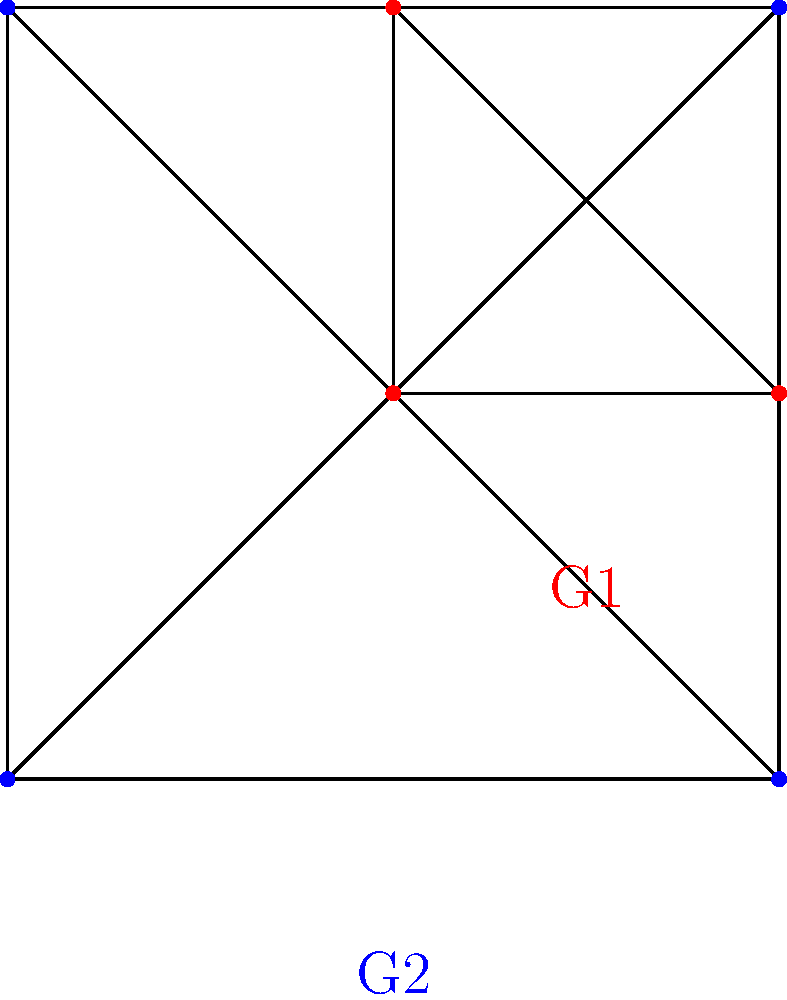Consider the two graphs G1 (red) and G2 (blue) shown above. Each graph represents a group where the vertices are the elements and the edges represent the group operation. Prove that these two groups are isomorphic by constructing an isomorphism $\phi: G1 \rightarrow G2$ that preserves the graph structure. What is the order of these groups? To prove that G1 and G2 are isomorphic, we need to construct a bijective function $\phi: G1 \rightarrow G2$ that preserves the group operation. Let's approach this step-by-step:

1) First, note that both graphs are complete graphs with 4 vertices. This means every vertex is connected to every other vertex.

2) In group theory, this structure represents Klein's four-group, also known as $V_4$ or $C_2 \times C_2$.

3) Let's label the vertices of G1 as $a, b, c, d$ and G2 as $w, x, y, z$.

4) We can define $\phi$ as follows:
   $\phi(a) = w$
   $\phi(b) = x$
   $\phi(c) = y$
   $\phi(d) = z$

5) This mapping is clearly bijective as it's a one-to-one correspondence between all elements.

6) To show that $\phi$ preserves the group operation, we need to check that for any two elements $g, h \in G1$, we have $\phi(g * h) = \phi(g) * \phi(h)$, where $*$ is the group operation.

7) In $V_4$, the group operation is such that any element multiplied by itself gives the identity, and the product of any two different non-identity elements gives the third non-identity element.

8) We can verify that this property holds for both G1 and G2, and that $\phi$ preserves this structure.

9) Therefore, $\phi$ is an isomorphism, and G1 and G2 are isomorphic.

10) The order of a group is the number of elements in the group. Both G1 and G2 have 4 vertices, so the order of these groups is 4.
Answer: The groups are isomorphic and have order 4. 